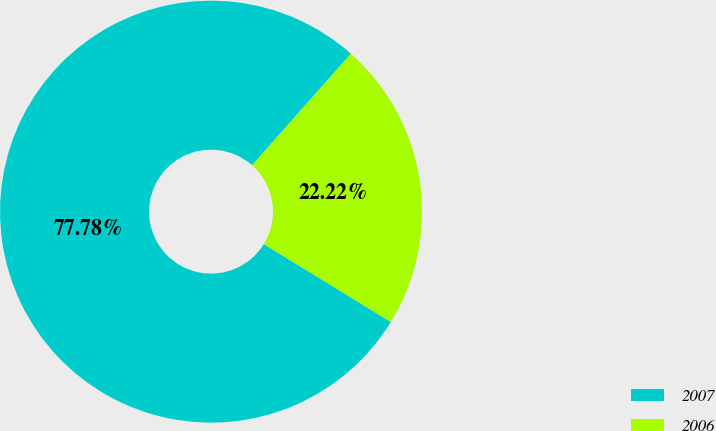Convert chart. <chart><loc_0><loc_0><loc_500><loc_500><pie_chart><fcel>2007<fcel>2006<nl><fcel>77.78%<fcel>22.22%<nl></chart> 